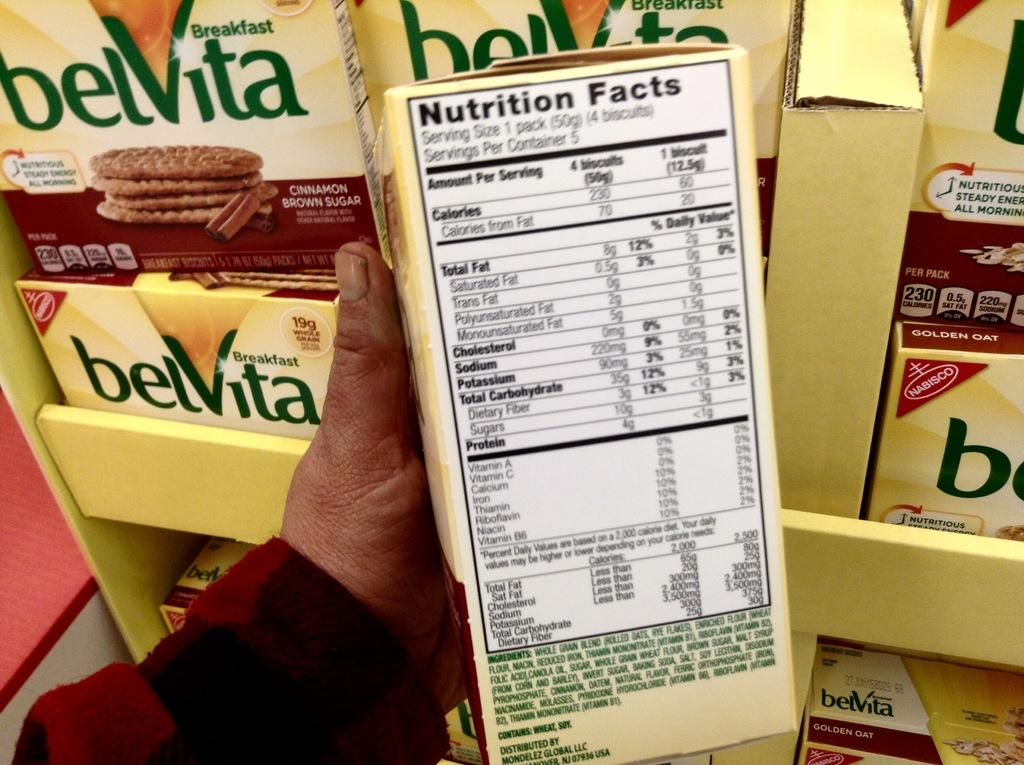<image>
Relay a brief, clear account of the picture shown. A person is holding a box of Belvita crackers that say Nutrition Facts on the side. 